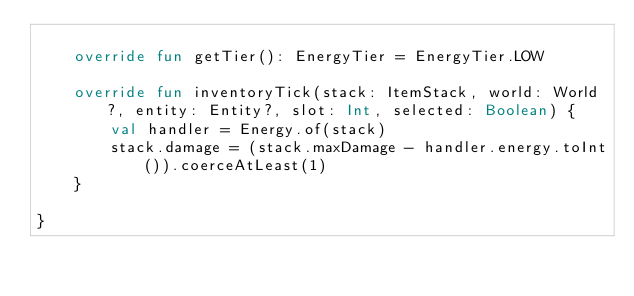Convert code to text. <code><loc_0><loc_0><loc_500><loc_500><_Kotlin_>
    override fun getTier(): EnergyTier = EnergyTier.LOW

    override fun inventoryTick(stack: ItemStack, world: World?, entity: Entity?, slot: Int, selected: Boolean) {
        val handler = Energy.of(stack)
        stack.damage = (stack.maxDamage - handler.energy.toInt()).coerceAtLeast(1)
    }

}</code> 